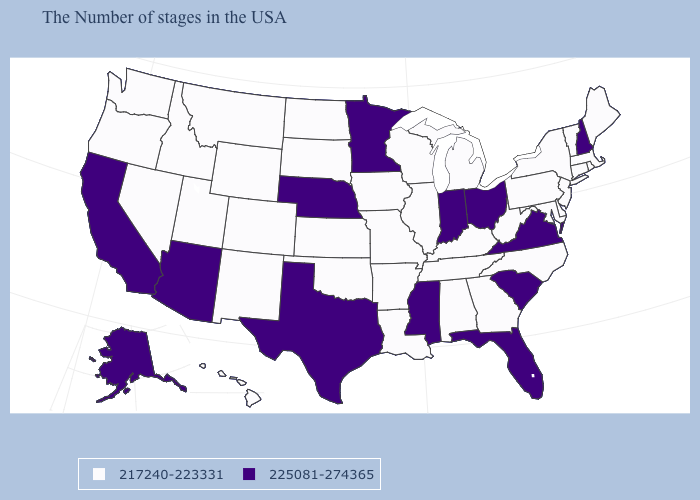Name the states that have a value in the range 217240-223331?
Concise answer only. Maine, Massachusetts, Rhode Island, Vermont, Connecticut, New York, New Jersey, Delaware, Maryland, Pennsylvania, North Carolina, West Virginia, Georgia, Michigan, Kentucky, Alabama, Tennessee, Wisconsin, Illinois, Louisiana, Missouri, Arkansas, Iowa, Kansas, Oklahoma, South Dakota, North Dakota, Wyoming, Colorado, New Mexico, Utah, Montana, Idaho, Nevada, Washington, Oregon, Hawaii. What is the lowest value in the West?
Keep it brief. 217240-223331. Which states have the lowest value in the MidWest?
Concise answer only. Michigan, Wisconsin, Illinois, Missouri, Iowa, Kansas, South Dakota, North Dakota. Among the states that border Wisconsin , which have the lowest value?
Quick response, please. Michigan, Illinois, Iowa. Name the states that have a value in the range 225081-274365?
Concise answer only. New Hampshire, Virginia, South Carolina, Ohio, Florida, Indiana, Mississippi, Minnesota, Nebraska, Texas, Arizona, California, Alaska. What is the value of Vermont?
Keep it brief. 217240-223331. Does New Hampshire have the same value as Arizona?
Keep it brief. Yes. What is the value of Nevada?
Be succinct. 217240-223331. Name the states that have a value in the range 217240-223331?
Quick response, please. Maine, Massachusetts, Rhode Island, Vermont, Connecticut, New York, New Jersey, Delaware, Maryland, Pennsylvania, North Carolina, West Virginia, Georgia, Michigan, Kentucky, Alabama, Tennessee, Wisconsin, Illinois, Louisiana, Missouri, Arkansas, Iowa, Kansas, Oklahoma, South Dakota, North Dakota, Wyoming, Colorado, New Mexico, Utah, Montana, Idaho, Nevada, Washington, Oregon, Hawaii. Does the map have missing data?
Short answer required. No. What is the value of North Dakota?
Concise answer only. 217240-223331. What is the value of North Carolina?
Quick response, please. 217240-223331. Name the states that have a value in the range 217240-223331?
Concise answer only. Maine, Massachusetts, Rhode Island, Vermont, Connecticut, New York, New Jersey, Delaware, Maryland, Pennsylvania, North Carolina, West Virginia, Georgia, Michigan, Kentucky, Alabama, Tennessee, Wisconsin, Illinois, Louisiana, Missouri, Arkansas, Iowa, Kansas, Oklahoma, South Dakota, North Dakota, Wyoming, Colorado, New Mexico, Utah, Montana, Idaho, Nevada, Washington, Oregon, Hawaii. 